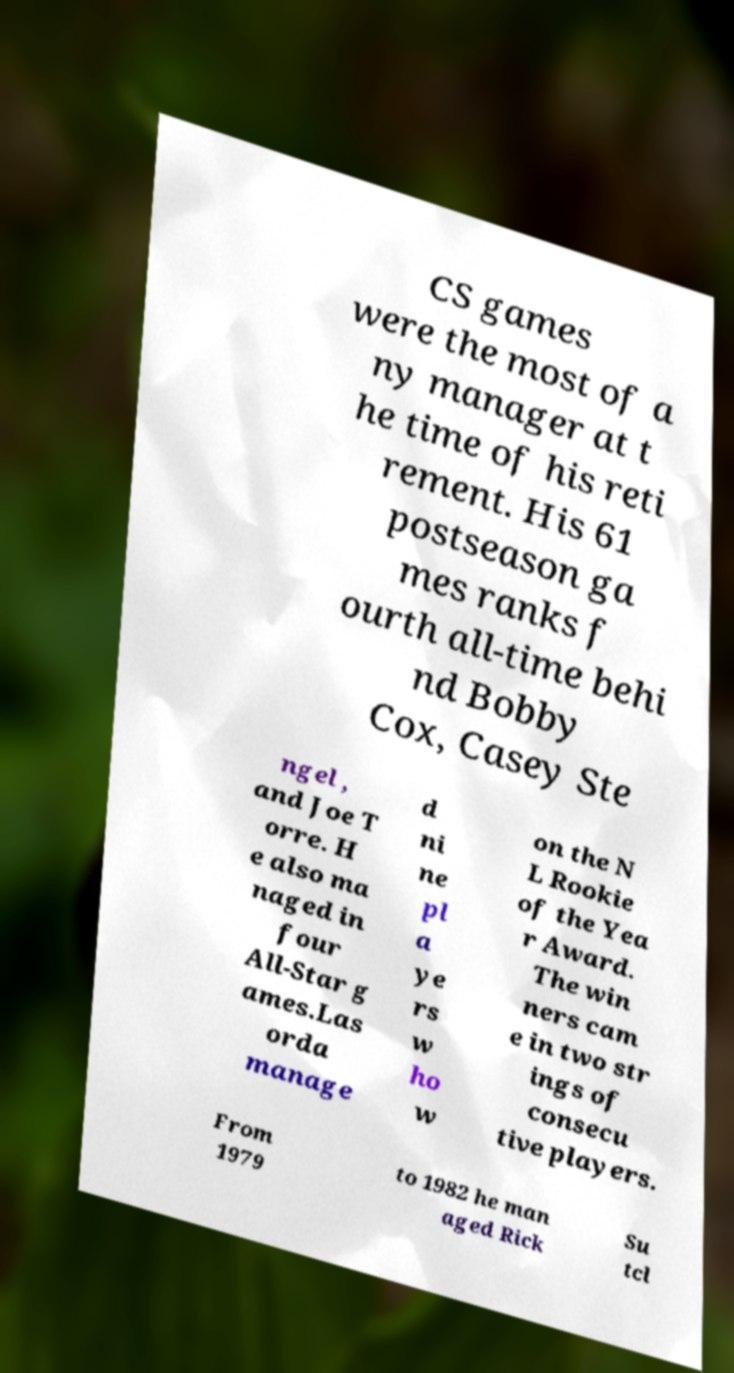Please identify and transcribe the text found in this image. CS games were the most of a ny manager at t he time of his reti rement. His 61 postseason ga mes ranks f ourth all-time behi nd Bobby Cox, Casey Ste ngel , and Joe T orre. H e also ma naged in four All-Star g ames.Las orda manage d ni ne pl a ye rs w ho w on the N L Rookie of the Yea r Award. The win ners cam e in two str ings of consecu tive players. From 1979 to 1982 he man aged Rick Su tcl 